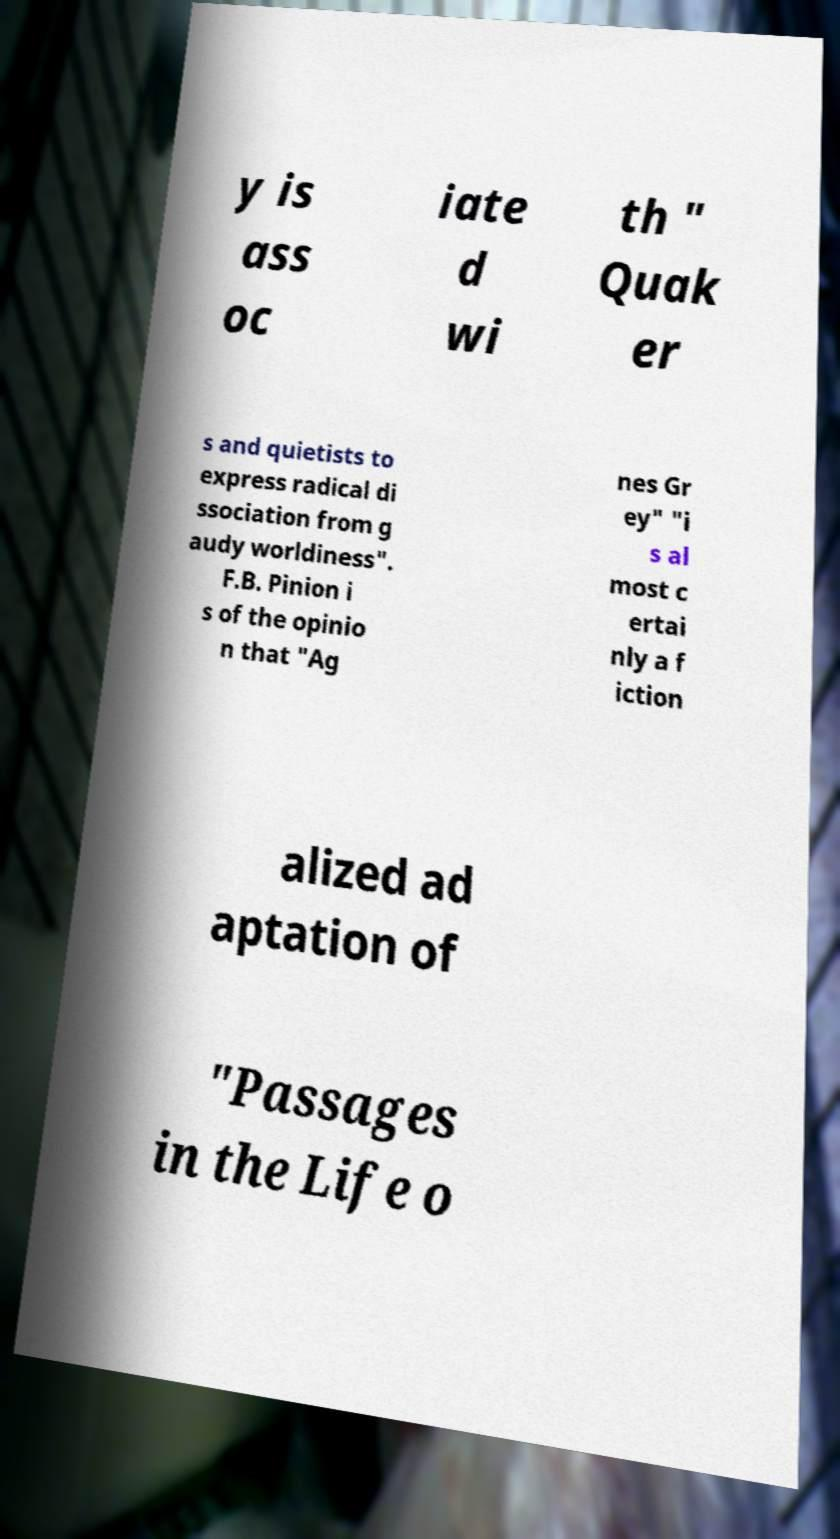For documentation purposes, I need the text within this image transcribed. Could you provide that? y is ass oc iate d wi th " Quak er s and quietists to express radical di ssociation from g audy worldiness". F.B. Pinion i s of the opinio n that "Ag nes Gr ey" "i s al most c ertai nly a f iction alized ad aptation of "Passages in the Life o 